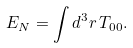<formula> <loc_0><loc_0><loc_500><loc_500>E _ { N } = \int d ^ { 3 } r \, T _ { 0 0 } .</formula> 